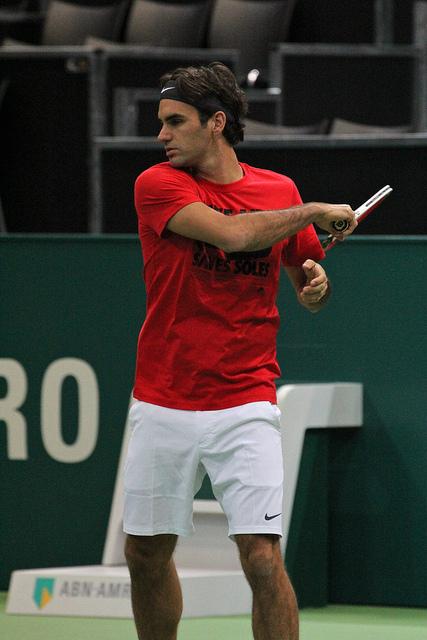What is the color of his shorts?
Be succinct. White. Is there anyone in the audience?
Concise answer only. No. What two letters do you see behind the player?
Write a very short answer. Ro. What letter is on the shirt?
Answer briefly. N. Who is that in the white shorts?
Quick response, please. Tennis player. 